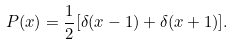Convert formula to latex. <formula><loc_0><loc_0><loc_500><loc_500>P ( x ) = \frac { 1 } { 2 } [ \delta ( x - 1 ) + \delta ( x + 1 ) ] .</formula> 